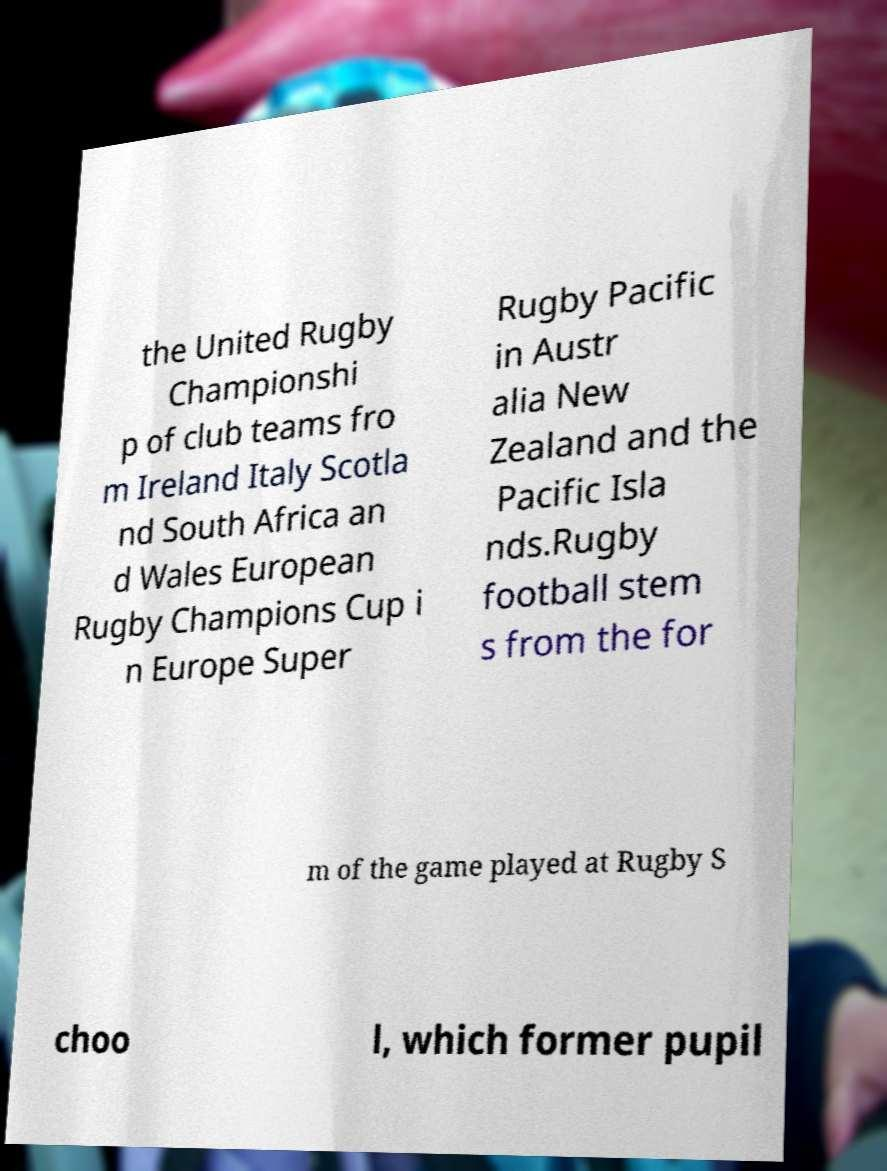Could you extract and type out the text from this image? the United Rugby Championshi p of club teams fro m Ireland Italy Scotla nd South Africa an d Wales European Rugby Champions Cup i n Europe Super Rugby Pacific in Austr alia New Zealand and the Pacific Isla nds.Rugby football stem s from the for m of the game played at Rugby S choo l, which former pupil 